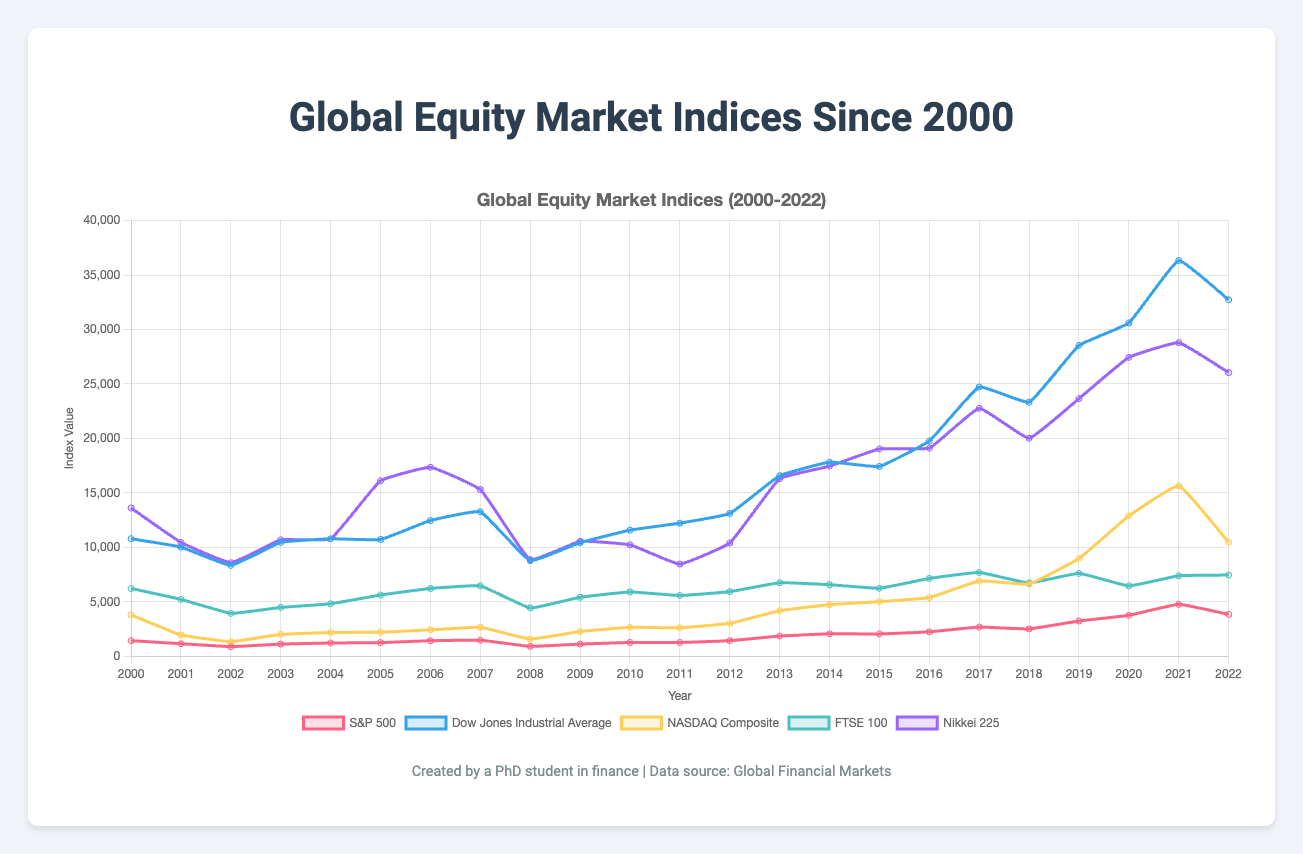What event caused the largest drop in the indices? By examining the plot, the largest drop occurred around 2008. This is likely due to the global financial crisis, which significantly impacted all the indices shown in the chart.
Answer: The global financial crisis in 2008 Between which two years did the S&P 500 show the largest increase? By comparing the S&P 500 line from year to year, the largest increase is seen between 2020 and 2021, where the index rose sharply from 3756.07 to 4766.18.
Answer: Between 2020 and 2021 Which index consistently had the highest value throughout the years? By observing the lines on the chart, the Dow Jones Industrial Average consistently had the highest values over the entire time period.
Answer: Dow Jones Industrial Average In 2008, which index had the smallest value? By looking at the year 2008, the NASDAQ Composite is the lowest among the indices with a value of 1577.03.
Answer: NASDAQ Composite By how much did the Nikkei 225 increase from 2005 to 2006? In 2005, the Nikkei 225 was 16111.43 and in 2006 it was 17354.41. The difference is 17354.41 - 16111.43 = 1242.98.
Answer: 1242.98 Which two indices were closest in value at the end of 2011? By examining the values for 2011, the S&P 500 and the NASDAQ Composite were the closest in value with 1257.60 and 2605.15 respectively; calculating the difference, they are the closest among other indices.
Answer: S&P 500 and Dow Jones Industrial Average How did the FTSE 100 index fare during the 2008 financial crisis (from 2007 to 2009)? The FTSE 100 dropped from 6456.90 in 2007 to 4434.20 in 2008, and then increased slightly to 5412.90 in 2009, indicating a substantial decline during the crisis and a partial recovery the following year.
Answer: It dropped significantly Between which years did the NASDAQ Composite have the least fluctuation? The NASDAQ Composite had the least fluctuation between 2010 and 2011, maintaining values close to 2652.87 and 2605.15 respectively.
Answer: Between 2010 and 2011 Which year saw the highest combined value of all five indices? To find this, sum the indices values for each year and compare. The year with the highest combined value is 2021.
Answer: 2021 